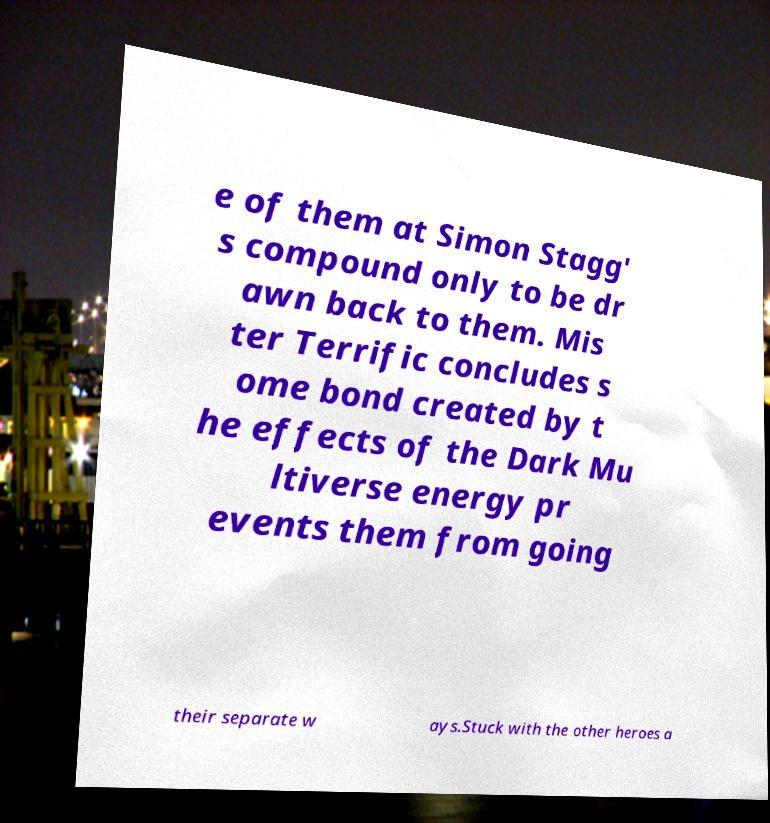Could you extract and type out the text from this image? e of them at Simon Stagg' s compound only to be dr awn back to them. Mis ter Terrific concludes s ome bond created by t he effects of the Dark Mu ltiverse energy pr events them from going their separate w ays.Stuck with the other heroes a 